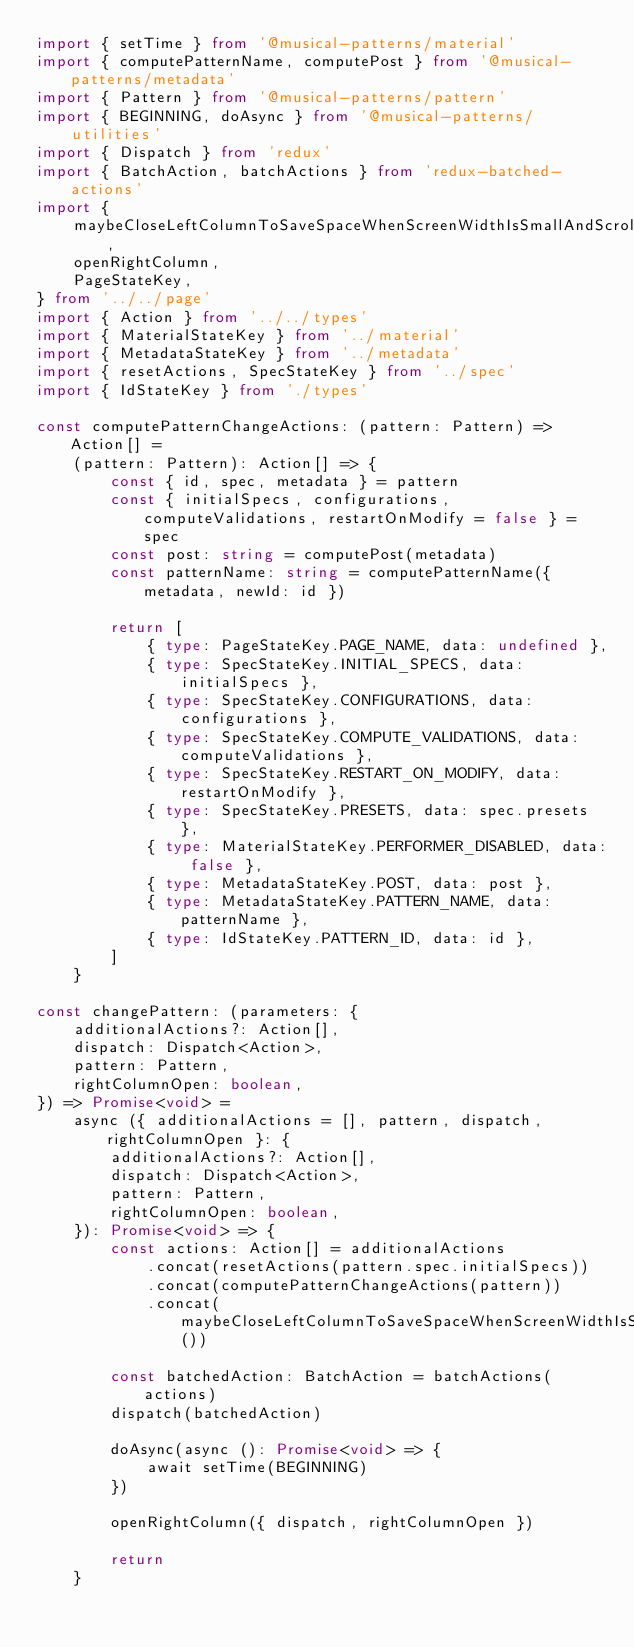Convert code to text. <code><loc_0><loc_0><loc_500><loc_500><_TypeScript_>import { setTime } from '@musical-patterns/material'
import { computePatternName, computePost } from '@musical-patterns/metadata'
import { Pattern } from '@musical-patterns/pattern'
import { BEGINNING, doAsync } from '@musical-patterns/utilities'
import { Dispatch } from 'redux'
import { BatchAction, batchActions } from 'redux-batched-actions'
import {
    maybeCloseLeftColumnToSaveSpaceWhenScreenWidthIsSmallAndScrollToTopActions,
    openRightColumn,
    PageStateKey,
} from '../../page'
import { Action } from '../../types'
import { MaterialStateKey } from '../material'
import { MetadataStateKey } from '../metadata'
import { resetActions, SpecStateKey } from '../spec'
import { IdStateKey } from './types'

const computePatternChangeActions: (pattern: Pattern) => Action[] =
    (pattern: Pattern): Action[] => {
        const { id, spec, metadata } = pattern
        const { initialSpecs, configurations, computeValidations, restartOnModify = false } = spec
        const post: string = computePost(metadata)
        const patternName: string = computePatternName({ metadata, newId: id })

        return [
            { type: PageStateKey.PAGE_NAME, data: undefined },
            { type: SpecStateKey.INITIAL_SPECS, data: initialSpecs },
            { type: SpecStateKey.CONFIGURATIONS, data: configurations },
            { type: SpecStateKey.COMPUTE_VALIDATIONS, data: computeValidations },
            { type: SpecStateKey.RESTART_ON_MODIFY, data: restartOnModify },
            { type: SpecStateKey.PRESETS, data: spec.presets },
            { type: MaterialStateKey.PERFORMER_DISABLED, data: false },
            { type: MetadataStateKey.POST, data: post },
            { type: MetadataStateKey.PATTERN_NAME, data: patternName },
            { type: IdStateKey.PATTERN_ID, data: id },
        ]
    }

const changePattern: (parameters: {
    additionalActions?: Action[],
    dispatch: Dispatch<Action>,
    pattern: Pattern,
    rightColumnOpen: boolean,
}) => Promise<void> =
    async ({ additionalActions = [], pattern, dispatch, rightColumnOpen }: {
        additionalActions?: Action[],
        dispatch: Dispatch<Action>,
        pattern: Pattern,
        rightColumnOpen: boolean,
    }): Promise<void> => {
        const actions: Action[] = additionalActions
            .concat(resetActions(pattern.spec.initialSpecs))
            .concat(computePatternChangeActions(pattern))
            .concat(maybeCloseLeftColumnToSaveSpaceWhenScreenWidthIsSmallAndScrollToTopActions())

        const batchedAction: BatchAction = batchActions(actions)
        dispatch(batchedAction)

        doAsync(async (): Promise<void> => {
            await setTime(BEGINNING)
        })

        openRightColumn({ dispatch, rightColumnOpen })

        return
    }
</code> 